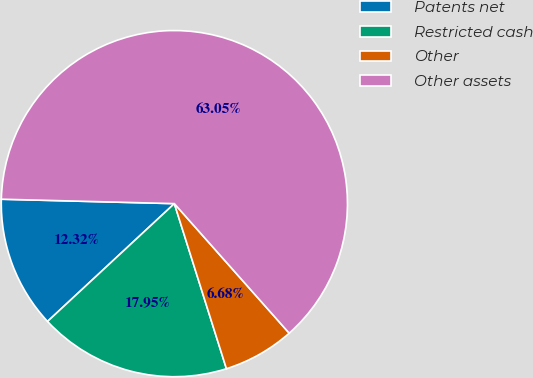Convert chart to OTSL. <chart><loc_0><loc_0><loc_500><loc_500><pie_chart><fcel>Patents net<fcel>Restricted cash<fcel>Other<fcel>Other assets<nl><fcel>12.32%<fcel>17.95%<fcel>6.68%<fcel>63.05%<nl></chart> 